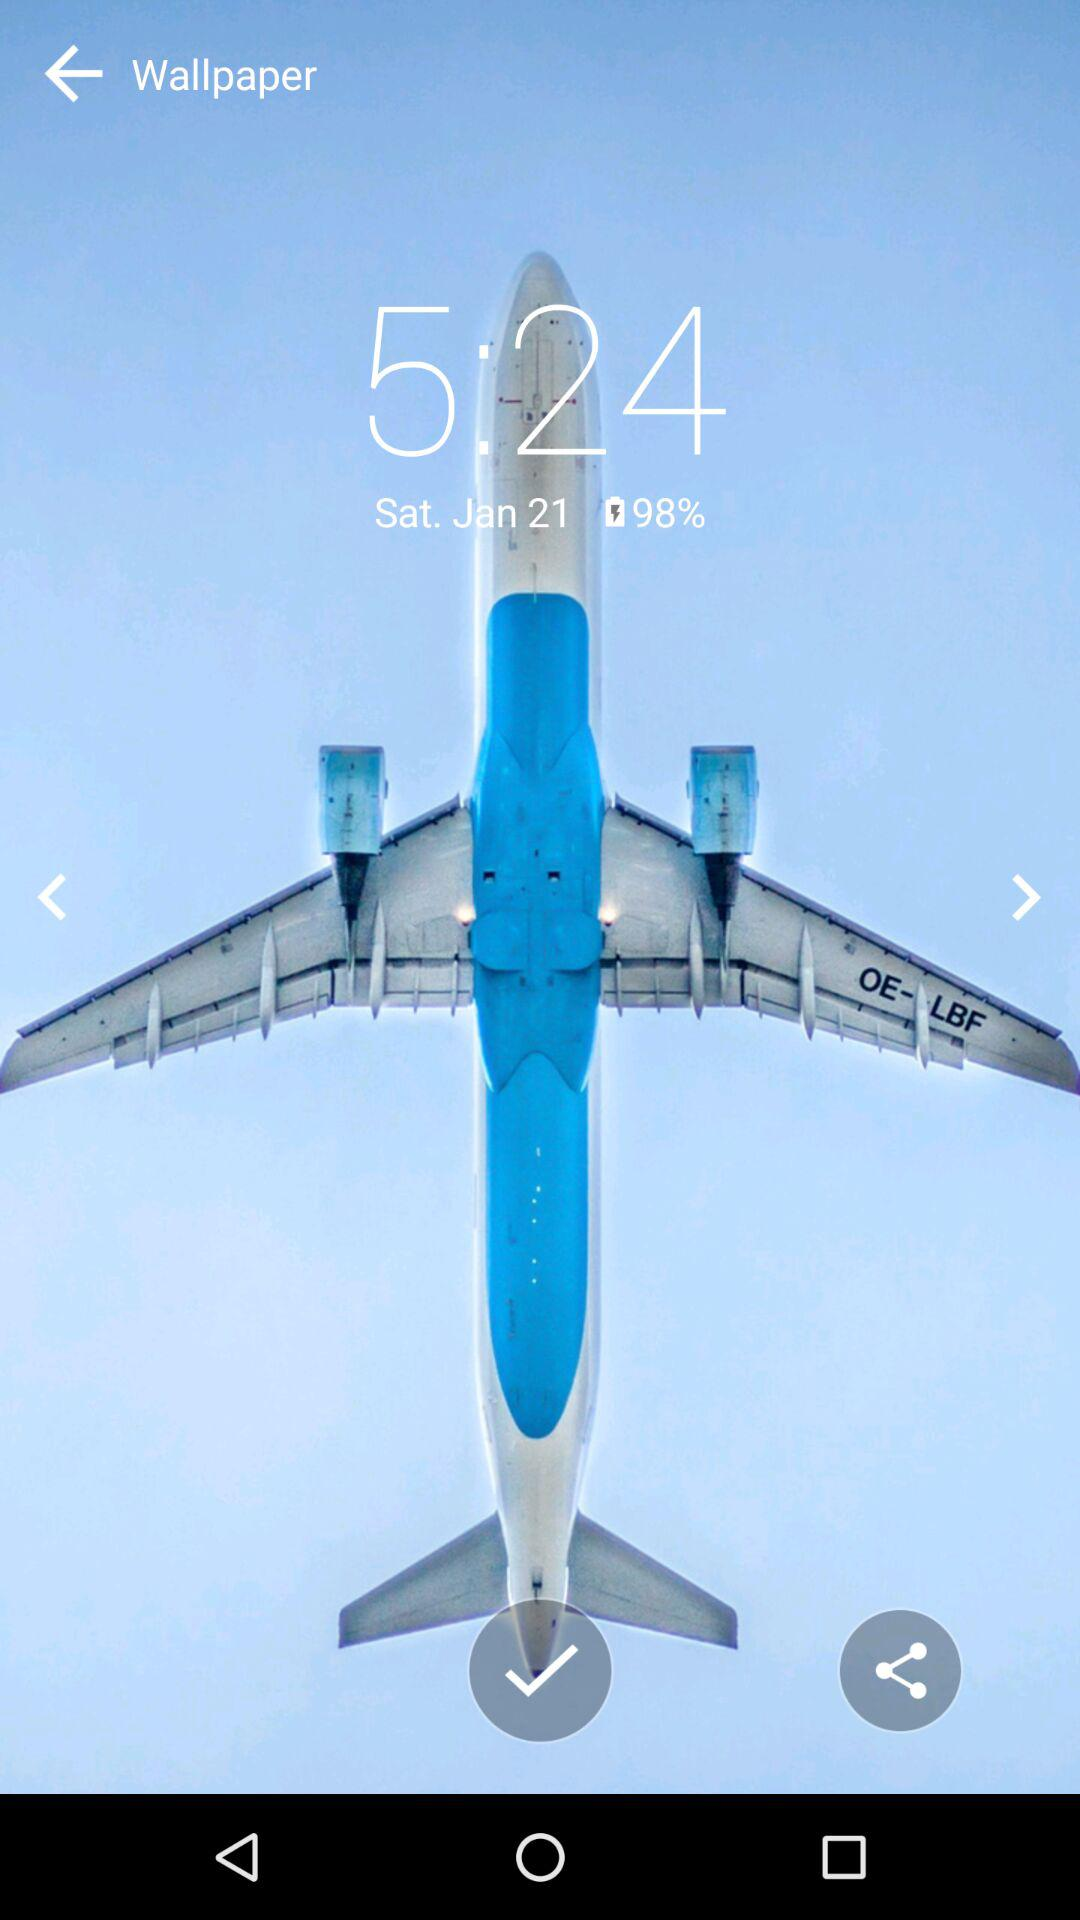What is the date and day? The date and day is Saturday, January 21. 